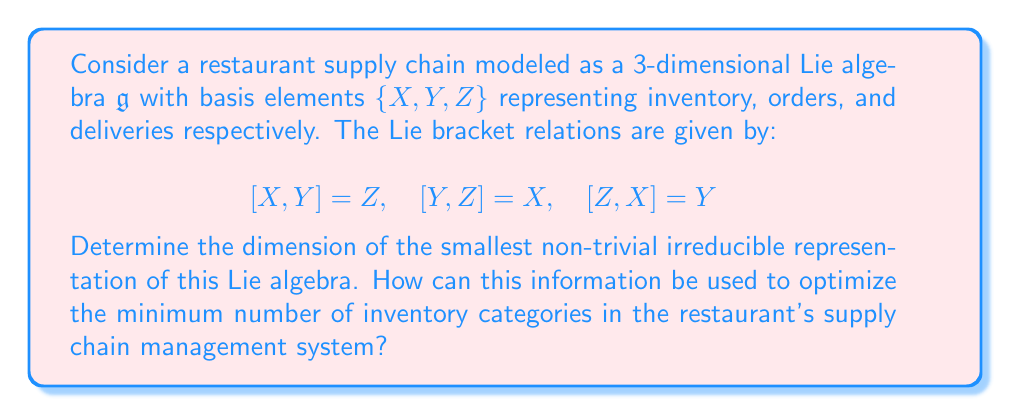Can you answer this question? To solve this problem, we'll follow these steps:

1) First, we need to identify the Lie algebra. The given relations correspond to the special linear Lie algebra $\mathfrak{sl}(2,\mathbb{C})$.

2) For $\mathfrak{sl}(2,\mathbb{C})$, we know that all finite-dimensional irreducible representations are characterized by their highest weight, which is a non-negative integer $n$.

3) The dimension of an irreducible representation with highest weight $n$ is given by $n+1$.

4) The smallest non-trivial irreducible representation would be the one with the smallest positive highest weight, which is $n=1$.

5) Therefore, the dimension of the smallest non-trivial irreducible representation is $1+1 = 2$.

In the context of inventory management:

6) Each dimension in the representation can be interpreted as a distinct category or aspect of inventory that needs to be tracked independently.

7) The fact that the smallest non-trivial representation is 2-dimensional suggests that at minimum, the restaurant should track at least two distinct aspects of their inventory.

8) These two aspects could represent, for example:
   a) Current stock levels
   b) Projected demand or upcoming orders

9) By focusing on these two key aspects, the restaurant can optimize its inventory management system while keeping it as simple and efficient as possible.

10) This minimal representation ensures that the restaurant captures the essential dynamics of its supply chain (represented by the Lie algebra structure) without unnecessary complexity.
Answer: 2-dimensional; Track 2 inventory aspects: current stock and projected demand. 